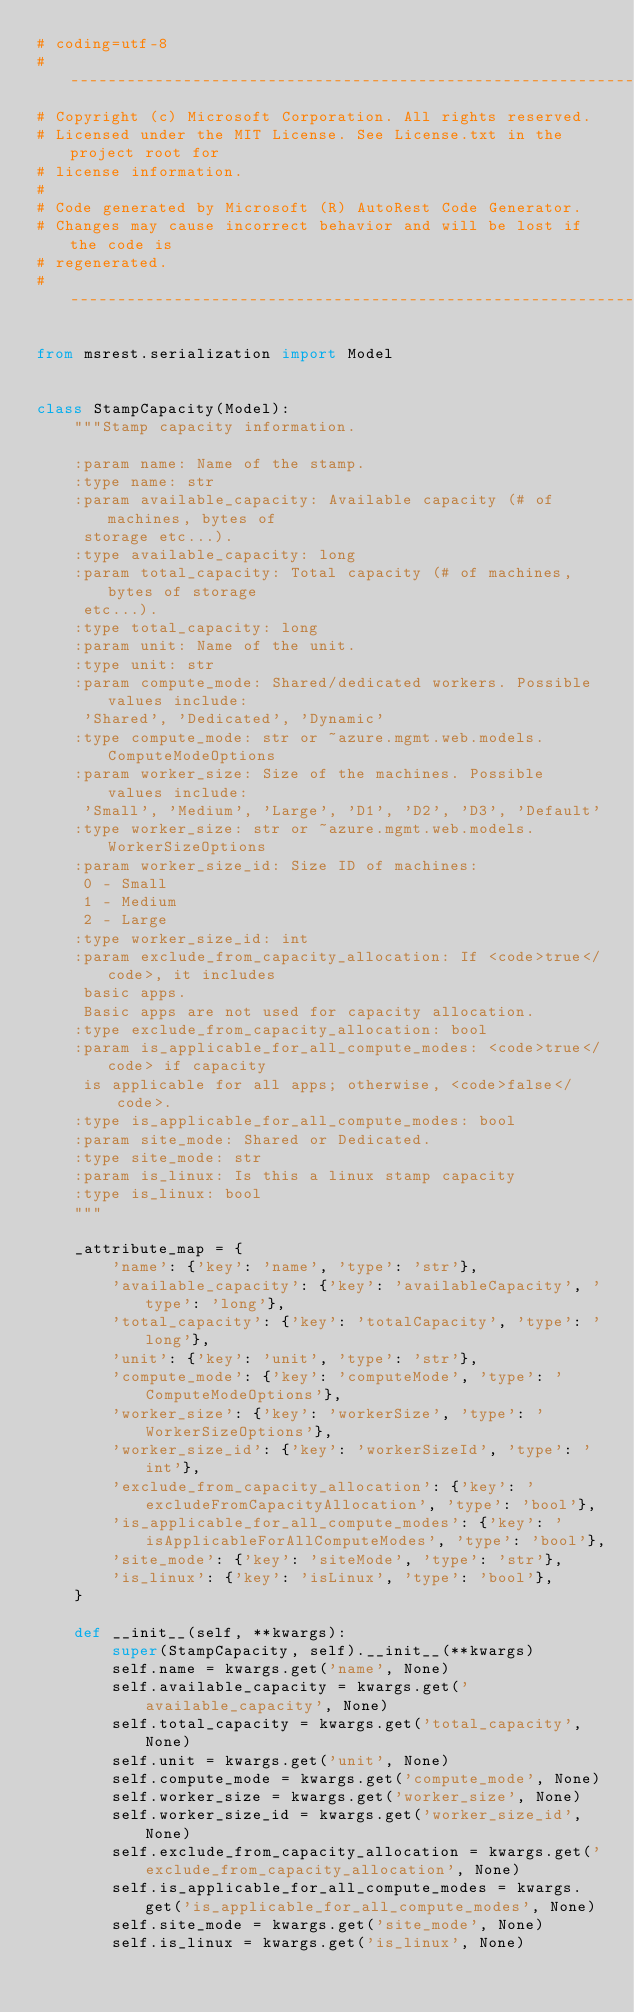<code> <loc_0><loc_0><loc_500><loc_500><_Python_># coding=utf-8
# --------------------------------------------------------------------------
# Copyright (c) Microsoft Corporation. All rights reserved.
# Licensed under the MIT License. See License.txt in the project root for
# license information.
#
# Code generated by Microsoft (R) AutoRest Code Generator.
# Changes may cause incorrect behavior and will be lost if the code is
# regenerated.
# --------------------------------------------------------------------------

from msrest.serialization import Model


class StampCapacity(Model):
    """Stamp capacity information.

    :param name: Name of the stamp.
    :type name: str
    :param available_capacity: Available capacity (# of machines, bytes of
     storage etc...).
    :type available_capacity: long
    :param total_capacity: Total capacity (# of machines, bytes of storage
     etc...).
    :type total_capacity: long
    :param unit: Name of the unit.
    :type unit: str
    :param compute_mode: Shared/dedicated workers. Possible values include:
     'Shared', 'Dedicated', 'Dynamic'
    :type compute_mode: str or ~azure.mgmt.web.models.ComputeModeOptions
    :param worker_size: Size of the machines. Possible values include:
     'Small', 'Medium', 'Large', 'D1', 'D2', 'D3', 'Default'
    :type worker_size: str or ~azure.mgmt.web.models.WorkerSizeOptions
    :param worker_size_id: Size ID of machines:
     0 - Small
     1 - Medium
     2 - Large
    :type worker_size_id: int
    :param exclude_from_capacity_allocation: If <code>true</code>, it includes
     basic apps.
     Basic apps are not used for capacity allocation.
    :type exclude_from_capacity_allocation: bool
    :param is_applicable_for_all_compute_modes: <code>true</code> if capacity
     is applicable for all apps; otherwise, <code>false</code>.
    :type is_applicable_for_all_compute_modes: bool
    :param site_mode: Shared or Dedicated.
    :type site_mode: str
    :param is_linux: Is this a linux stamp capacity
    :type is_linux: bool
    """

    _attribute_map = {
        'name': {'key': 'name', 'type': 'str'},
        'available_capacity': {'key': 'availableCapacity', 'type': 'long'},
        'total_capacity': {'key': 'totalCapacity', 'type': 'long'},
        'unit': {'key': 'unit', 'type': 'str'},
        'compute_mode': {'key': 'computeMode', 'type': 'ComputeModeOptions'},
        'worker_size': {'key': 'workerSize', 'type': 'WorkerSizeOptions'},
        'worker_size_id': {'key': 'workerSizeId', 'type': 'int'},
        'exclude_from_capacity_allocation': {'key': 'excludeFromCapacityAllocation', 'type': 'bool'},
        'is_applicable_for_all_compute_modes': {'key': 'isApplicableForAllComputeModes', 'type': 'bool'},
        'site_mode': {'key': 'siteMode', 'type': 'str'},
        'is_linux': {'key': 'isLinux', 'type': 'bool'},
    }

    def __init__(self, **kwargs):
        super(StampCapacity, self).__init__(**kwargs)
        self.name = kwargs.get('name', None)
        self.available_capacity = kwargs.get('available_capacity', None)
        self.total_capacity = kwargs.get('total_capacity', None)
        self.unit = kwargs.get('unit', None)
        self.compute_mode = kwargs.get('compute_mode', None)
        self.worker_size = kwargs.get('worker_size', None)
        self.worker_size_id = kwargs.get('worker_size_id', None)
        self.exclude_from_capacity_allocation = kwargs.get('exclude_from_capacity_allocation', None)
        self.is_applicable_for_all_compute_modes = kwargs.get('is_applicable_for_all_compute_modes', None)
        self.site_mode = kwargs.get('site_mode', None)
        self.is_linux = kwargs.get('is_linux', None)
</code> 